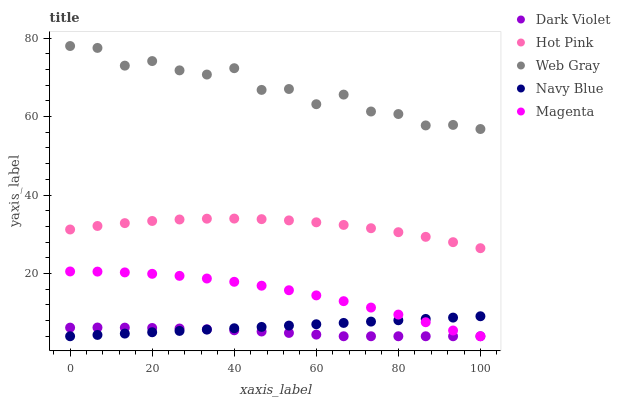Does Dark Violet have the minimum area under the curve?
Answer yes or no. Yes. Does Web Gray have the maximum area under the curve?
Answer yes or no. Yes. Does Magenta have the minimum area under the curve?
Answer yes or no. No. Does Magenta have the maximum area under the curve?
Answer yes or no. No. Is Navy Blue the smoothest?
Answer yes or no. Yes. Is Web Gray the roughest?
Answer yes or no. Yes. Is Magenta the smoothest?
Answer yes or no. No. Is Magenta the roughest?
Answer yes or no. No. Does Navy Blue have the lowest value?
Answer yes or no. Yes. Does Hot Pink have the lowest value?
Answer yes or no. No. Does Web Gray have the highest value?
Answer yes or no. Yes. Does Magenta have the highest value?
Answer yes or no. No. Is Navy Blue less than Hot Pink?
Answer yes or no. Yes. Is Hot Pink greater than Magenta?
Answer yes or no. Yes. Does Dark Violet intersect Navy Blue?
Answer yes or no. Yes. Is Dark Violet less than Navy Blue?
Answer yes or no. No. Is Dark Violet greater than Navy Blue?
Answer yes or no. No. Does Navy Blue intersect Hot Pink?
Answer yes or no. No. 